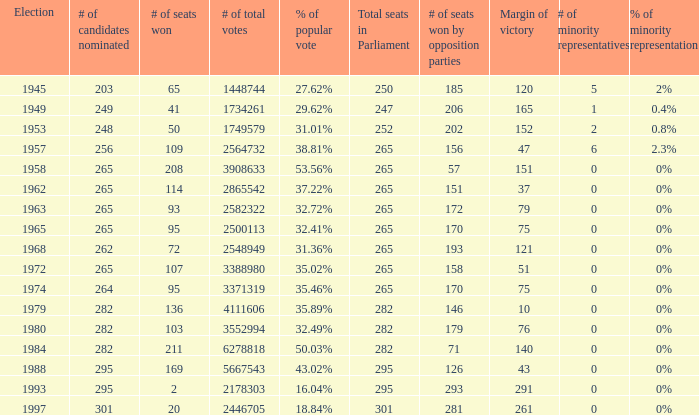Can you parse all the data within this table? {'header': ['Election', '# of candidates nominated', '# of seats won', '# of total votes', '% of popular vote', 'Total seats in Parliament', '# of seats won by opposition parties', 'Margin of victory', '# of minority representatives', '% of minority representation'], 'rows': [['1945', '203', '65', '1448744', '27.62%', '250', '185', '120', '5', '2%'], ['1949', '249', '41', '1734261', '29.62%', '247', '206', '165', '1', '0.4%'], ['1953', '248', '50', '1749579', '31.01%', '252', '202', '152', '2', '0.8%'], ['1957', '256', '109', '2564732', '38.81%', '265', '156', '47', '6', '2.3%'], ['1958', '265', '208', '3908633', '53.56%', '265', '57', '151', '0', '0%'], ['1962', '265', '114', '2865542', '37.22%', '265', '151', '37', '0', '0%'], ['1963', '265', '93', '2582322', '32.72%', '265', '172', '79', '0', '0%'], ['1965', '265', '95', '2500113', '32.41%', '265', '170', '75', '0', '0%'], ['1968', '262', '72', '2548949', '31.36%', '265', '193', '121', '0', '0%'], ['1972', '265', '107', '3388980', '35.02%', '265', '158', '51', '0', '0%'], ['1974', '264', '95', '3371319', '35.46%', '265', '170', '75', '0', '0%'], ['1979', '282', '136', '4111606', '35.89%', '282', '146', '10', '0', '0%'], ['1980', '282', '103', '3552994', '32.49%', '282', '179', '76', '0', '0%'], ['1984', '282', '211', '6278818', '50.03%', '282', '71', '140', '0', '0%'], ['1988', '295', '169', '5667543', '43.02%', '295', '126', '43', '0', '0%'], ['1993', '295', '2', '2178303', '16.04%', '295', '293', '291', '0', '0%'], ['1997', '301', '20', '2446705', '18.84%', '301', '281', '261', '0', '0%']]} What is the # of seats one for the election in 1974? 95.0. 